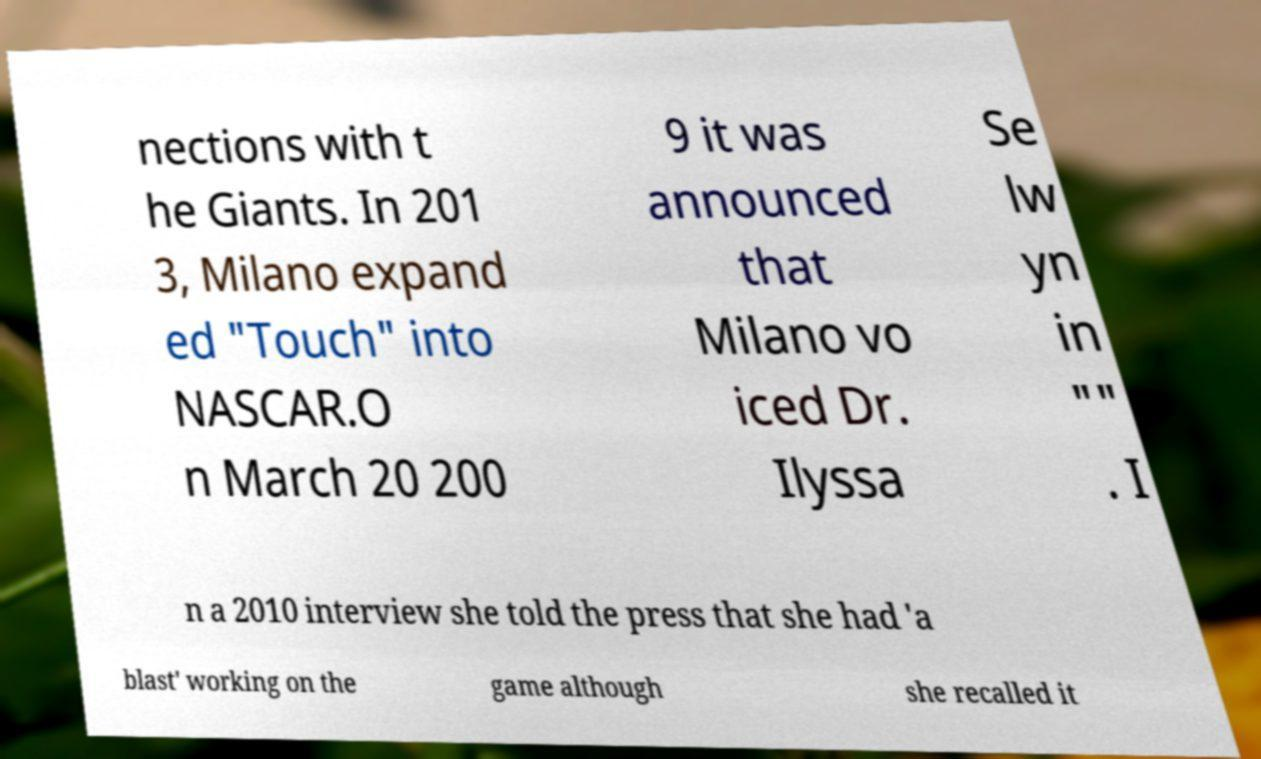Could you extract and type out the text from this image? nections with t he Giants. In 201 3, Milano expand ed "Touch" into NASCAR.O n March 20 200 9 it was announced that Milano vo iced Dr. Ilyssa Se lw yn in "" . I n a 2010 interview she told the press that she had 'a blast' working on the game although she recalled it 